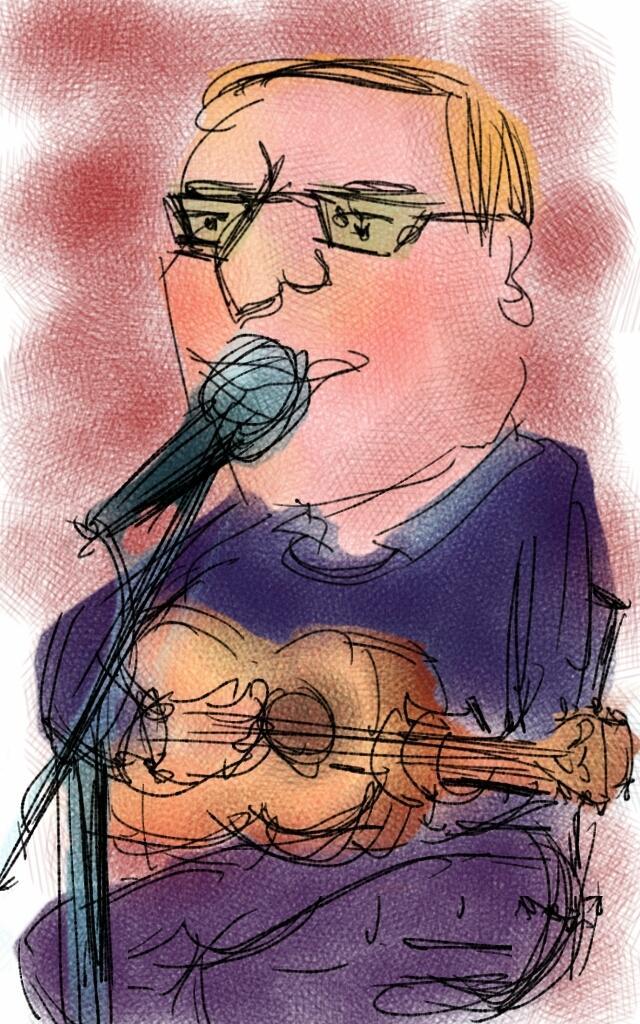Please provide a concise description of this image. In this picture, we see an illustration or an art of the man who is wearing the spectacles. He is holding a guitar in his hand and he might be singing the song on the microphone. In the background, it is dark red in color. 